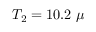<formula> <loc_0><loc_0><loc_500><loc_500>T _ { 2 } = 1 0 . 2 \mu</formula> 